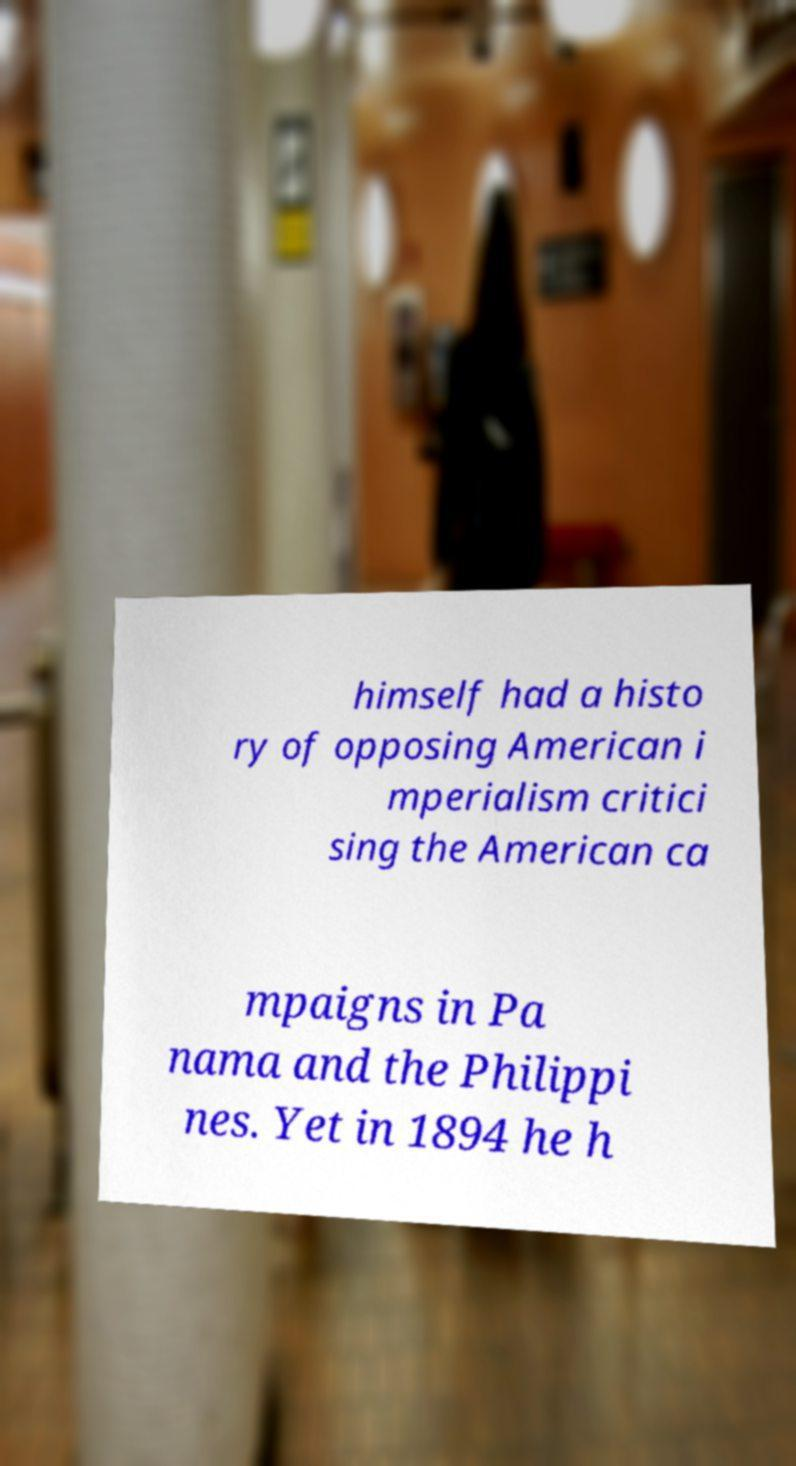Could you assist in decoding the text presented in this image and type it out clearly? himself had a histo ry of opposing American i mperialism critici sing the American ca mpaigns in Pa nama and the Philippi nes. Yet in 1894 he h 